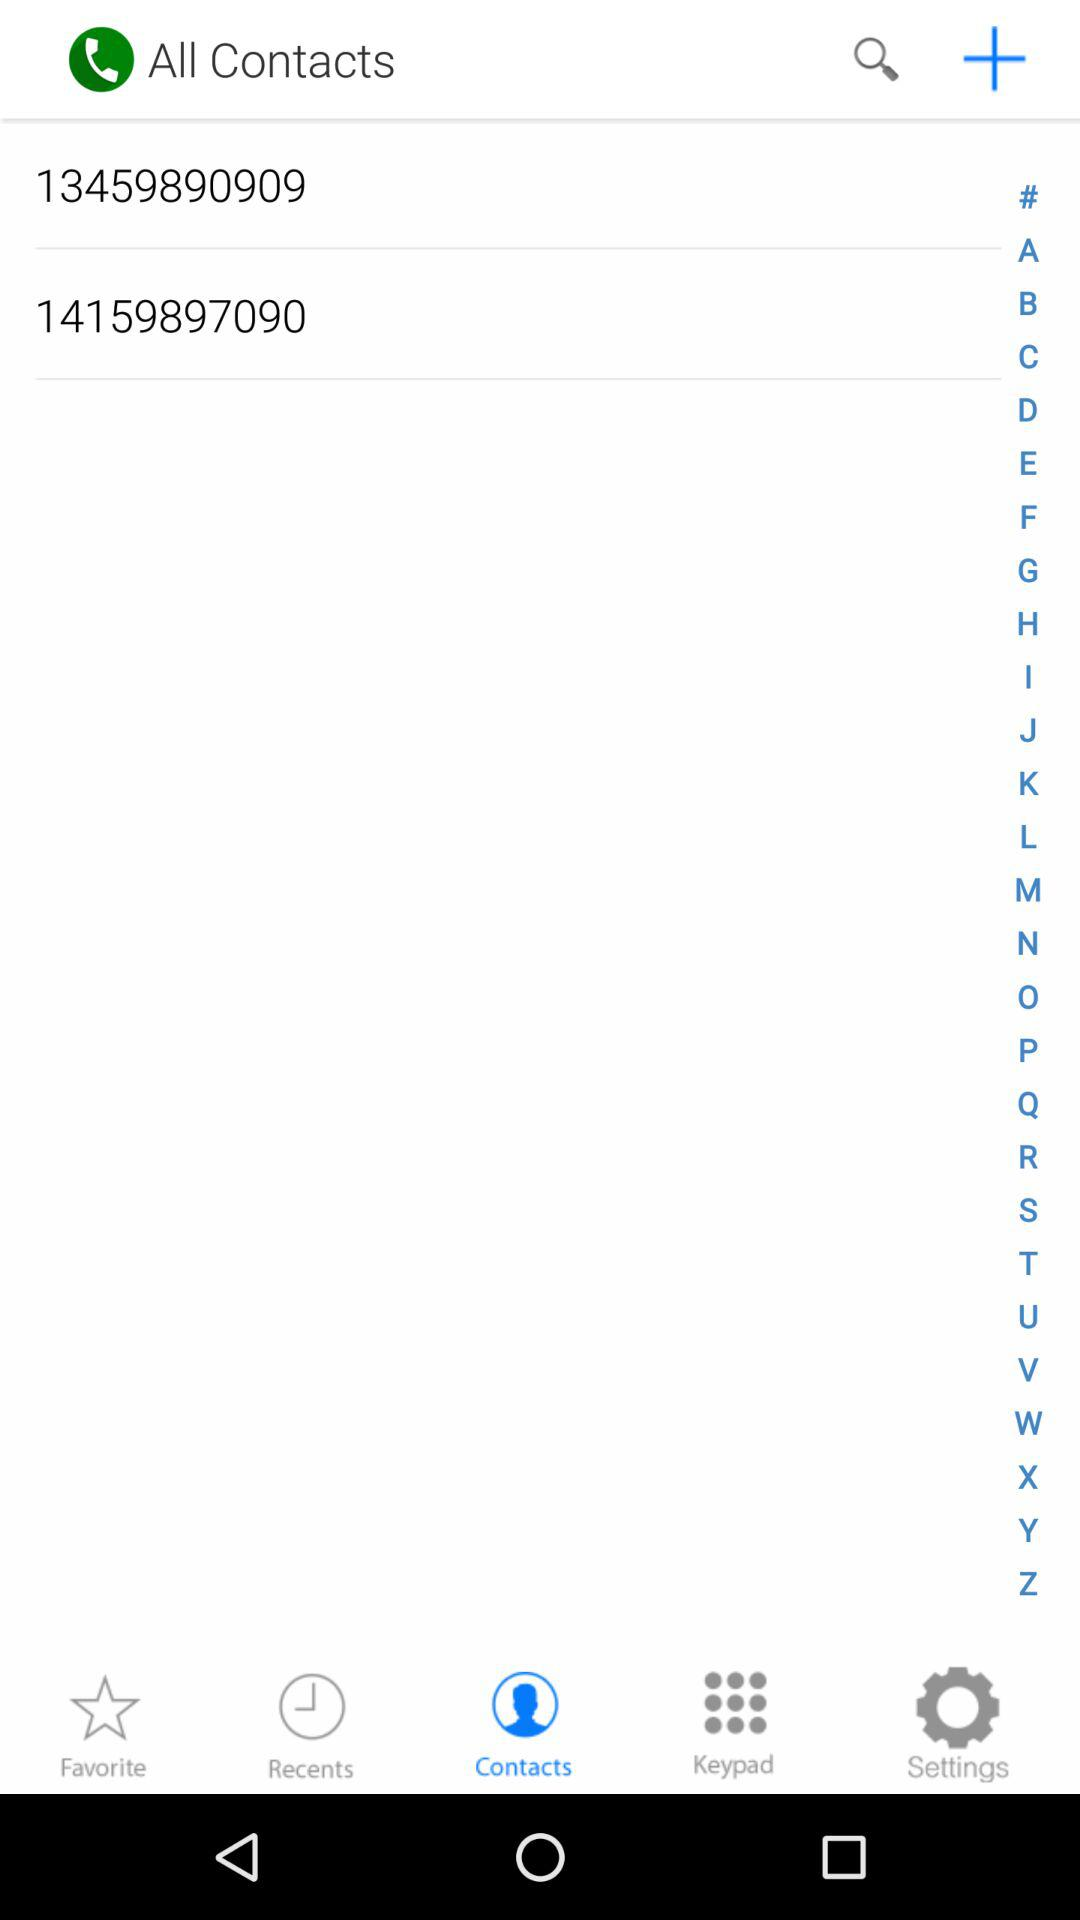Which option is selected? The selected option is "Contacts". 